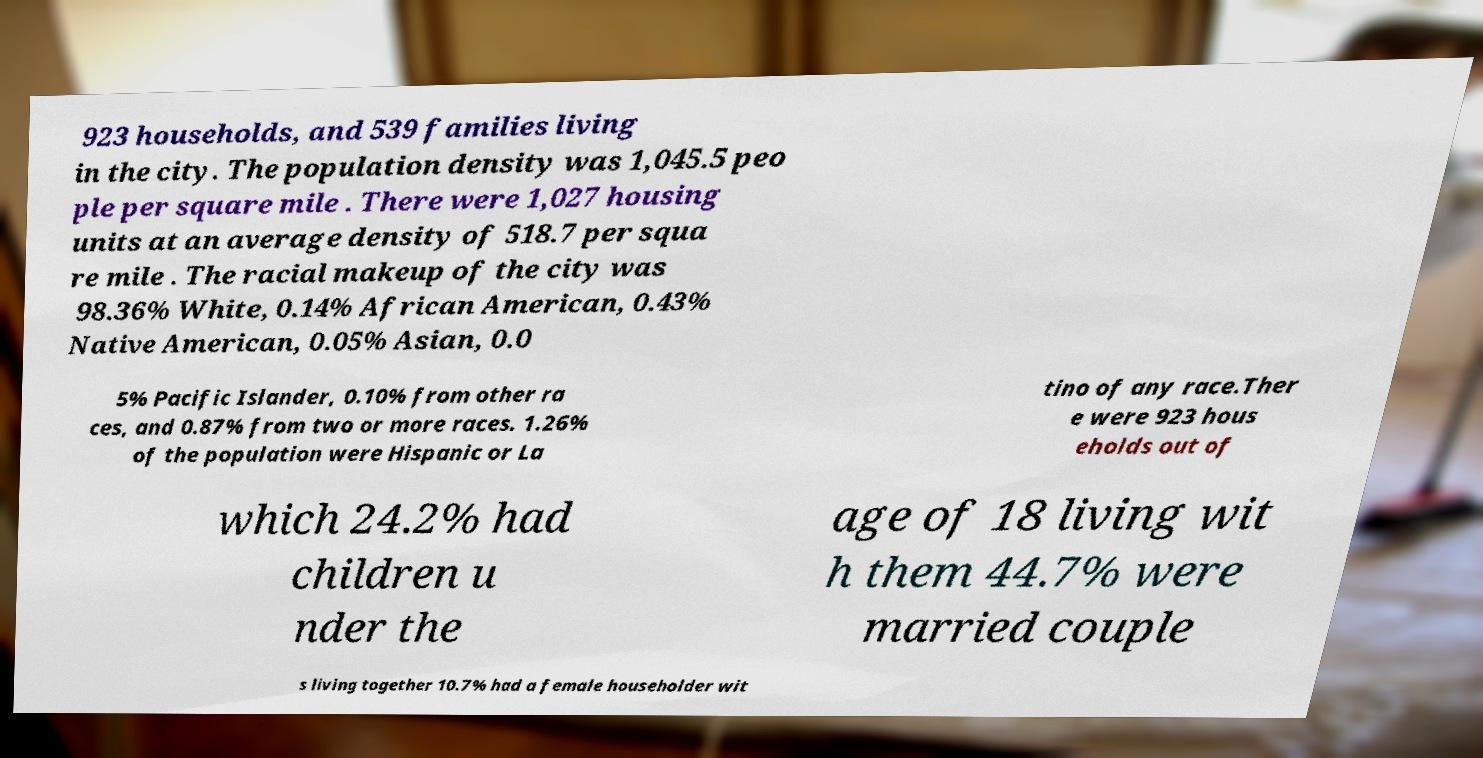For documentation purposes, I need the text within this image transcribed. Could you provide that? 923 households, and 539 families living in the city. The population density was 1,045.5 peo ple per square mile . There were 1,027 housing units at an average density of 518.7 per squa re mile . The racial makeup of the city was 98.36% White, 0.14% African American, 0.43% Native American, 0.05% Asian, 0.0 5% Pacific Islander, 0.10% from other ra ces, and 0.87% from two or more races. 1.26% of the population were Hispanic or La tino of any race.Ther e were 923 hous eholds out of which 24.2% had children u nder the age of 18 living wit h them 44.7% were married couple s living together 10.7% had a female householder wit 